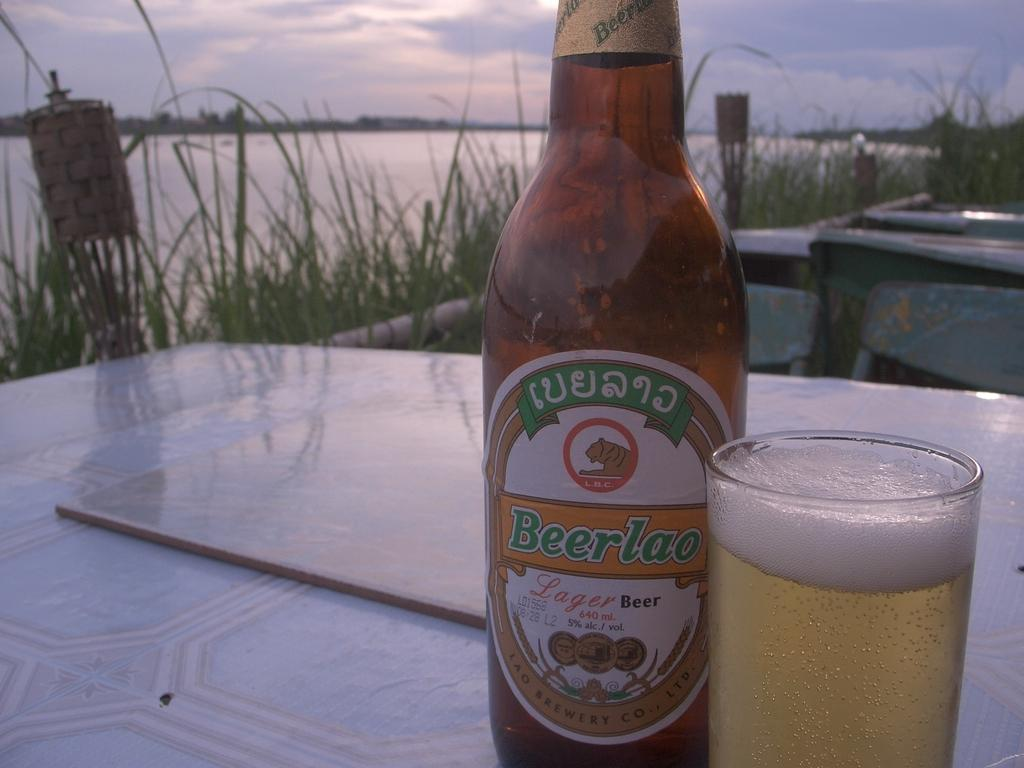What type of alcoholic beverage is in the bottle in the image? There is a beer bottle in the image. What type of glass is holding the beer in the image? There is a wine glass with beer in the image. What can be seen in the background of the image? There are plants, tables, water, trees, and the sky visible in the background of the image. What historical event is being commemorated by the monkey in the image? There is no monkey present in the image, so it cannot be commemorating any historical event. 